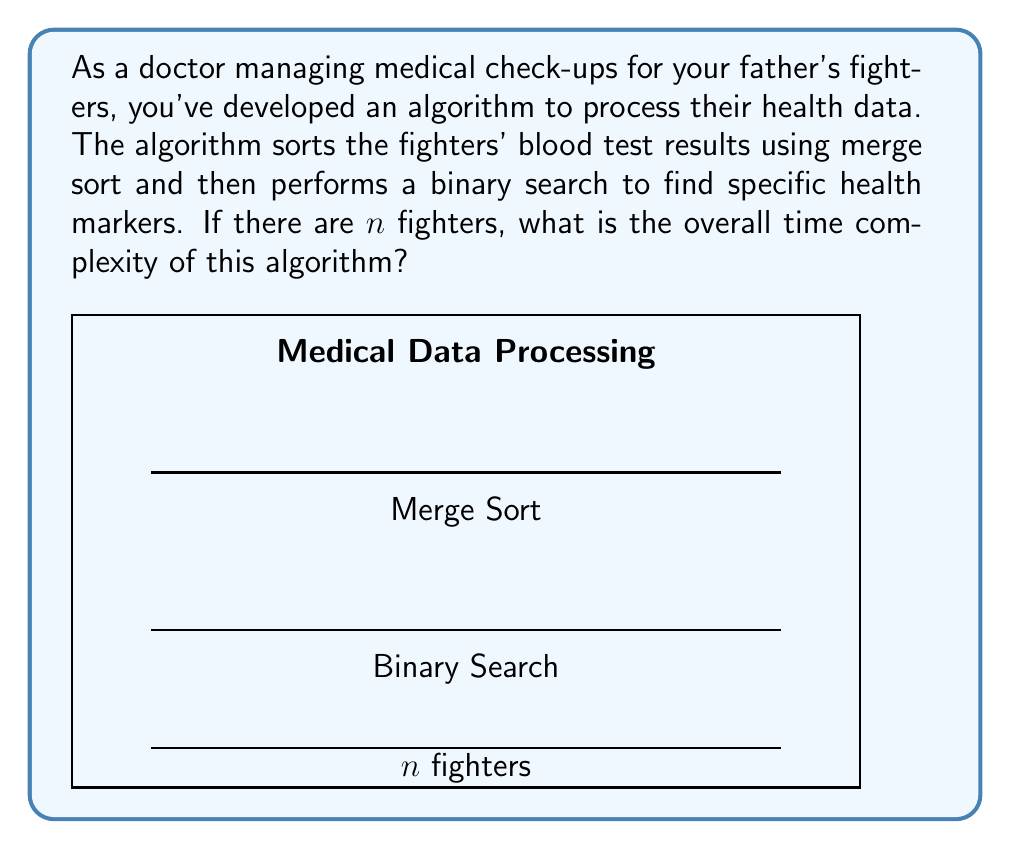Provide a solution to this math problem. Let's analyze this algorithm step by step:

1) Merge Sort:
   - Merge sort has a time complexity of $O(n \log n)$, where $n$ is the number of elements to be sorted.
   - In this case, $n$ represents the number of fighters.

2) Binary Search:
   - Binary search has a time complexity of $O(\log n)$ for a single search operation.
   - However, we're not told how many searches are performed. Let's assume we do a constant number of searches (e.g., for specific health markers), independent of $n$.

3) Overall complexity:
   - The algorithm first performs merge sort, then does a constant number of binary searches.
   - We can represent this as: $T(n) = O(n \log n) + c \cdot O(\log n)$, where $c$ is some constant.

4) Simplifying:
   - $T(n) = O(n \log n) + O(\log n)$
   - The $O(n \log n)$ term dominates the $O(\log n)$ term for large $n$.

5) Therefore, the overall time complexity is $O(n \log n)$.

This complexity ensures that the algorithm can efficiently handle large numbers of fighters, scaling reasonably well as the number of fighters increases.
Answer: $O(n \log n)$ 